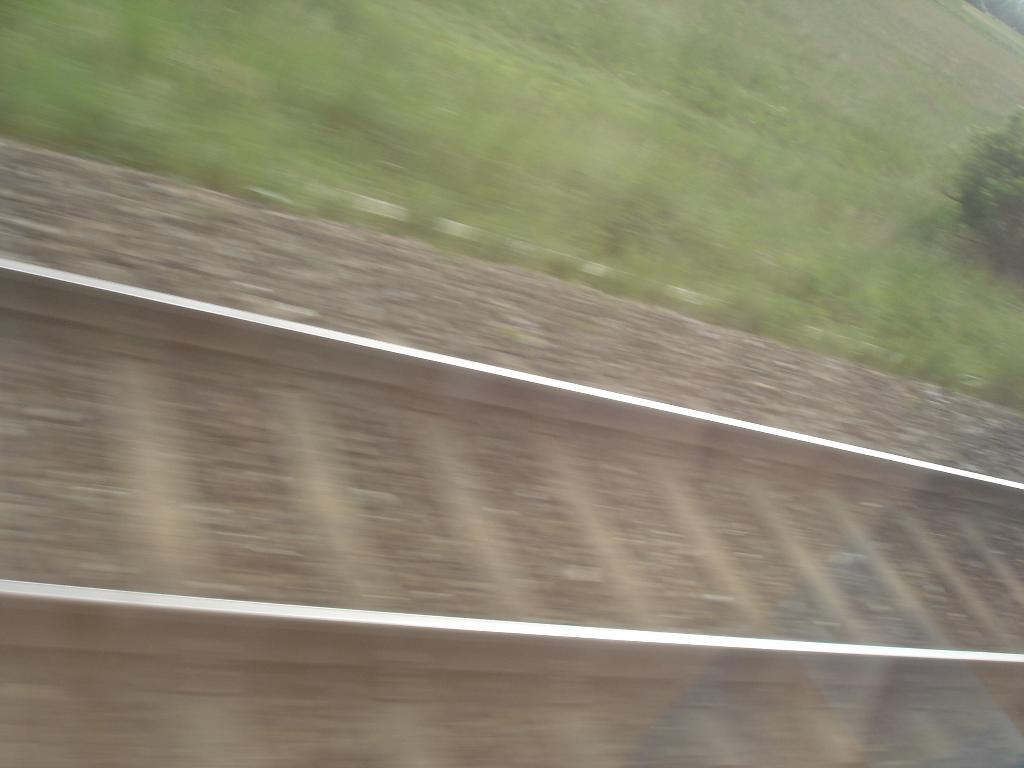What is the main subject in the middle of the image? There is a railway track in the middle of the image. Are there any objects or features on the railway track? Yes, there are stones on the railway track. What can be seen beside the railway track? There are small plants beside the railway track. What type of cracker is being used as a punishment for the plants beside the railway track? There is no cracker or punishment present in the image; it only features a railway track, stones, and small plants. 